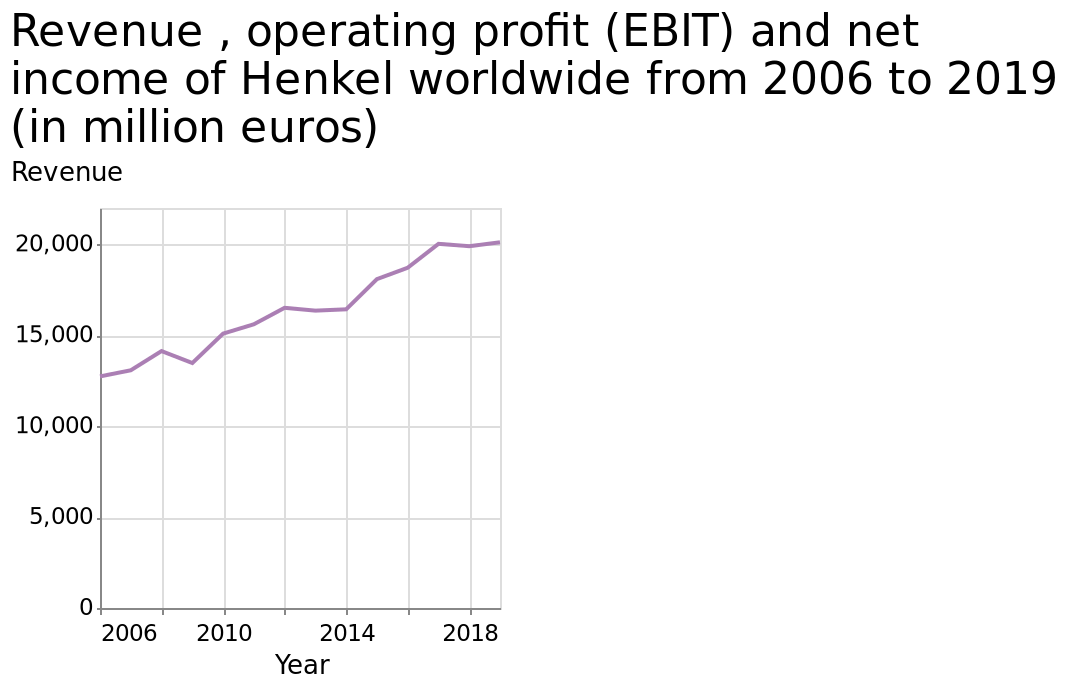<image>
What was Henkel's revenue in 2006?  Henkel's revenue was around 13000 million euros in 2006. What does the line plot represent for the variable "Revenue"?  The line plot represents the data for "Revenue" of Henkel worldwide from 2006 to 2019 in million euros. Describe the following image in detail Here a is a line plot titled Revenue , operating profit (EBIT) and net income of Henkel worldwide from 2006 to 2019 (in million euros). The x-axis plots Year while the y-axis plots Revenue. Was there any stable period for Henkel's revenue? Yes, Henkel's revenue remained stable between 2012 and 2014, and again between 2017 and 2019. Did Henkel's revenue decrease during any period? Yes, Henkel's revenue fell between 2008 and 2009. Was Henkel's revenue around 130 million euros in 2006? No. Henkel's revenue was around 13000 million euros in 2006. 